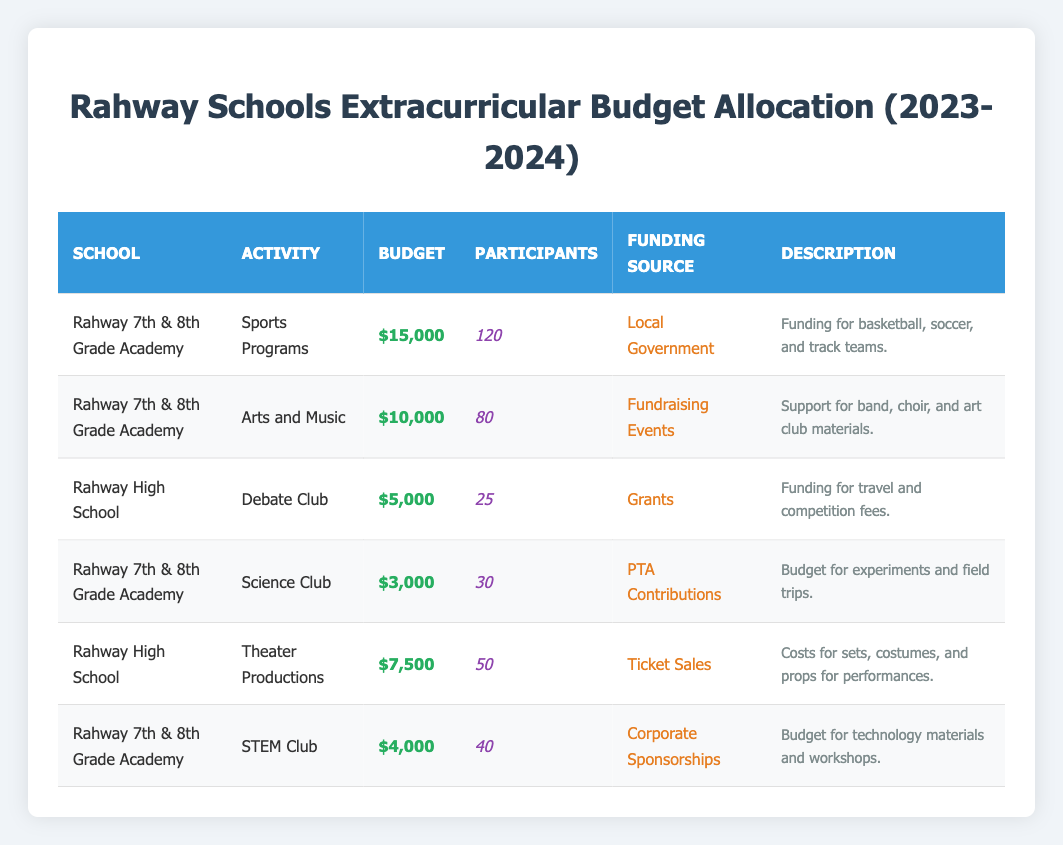What is the allocated budget for the Sports Programs at Rahway 7th & 8th Grade Academy? The table lists the allocated budget for Sports Programs at Rahway 7th & 8th Grade Academy as $15,000.
Answer: $15,000 How many participants are involved in the Arts and Music activities at Rahway 7th & 8th Grade Academy? The table shows that there are 80 participants in the Arts and Music activities at Rahway 7th & 8th Grade Academy.
Answer: 80 Which funding source is used for the Science Club at Rahway 7th & 8th Grade Academy? According to the table, the funding source for the Science Club at Rahway 7th & 8th Grade Academy is PTA Contributions.
Answer: PTA Contributions What is the total budget allocated for extracurricular activities at Rahway 7th & 8th Grade Academy? The table shows the following budgets: Sports Programs ($15,000), Arts and Music ($10,000), Science Club ($3,000), and STEM Club ($4,000). Summing these gives: $15,000 + $10,000 + $3,000 + $4,000 = $32,000.
Answer: $32,000 Is the Debate Club at Rahway High School funded by local government? The table indicates that the funding source for the Debate Club at Rahway High School is Grants, not local government.
Answer: No How much more budget is allocated to Sports Programs compared to the STEM Club at Rahway 7th & 8th Grade Academy? The budget for Sports Programs is $15,000, while for the STEM Club it is $4,000. The difference is calculated as: $15,000 - $4,000 = $11,000.
Answer: $11,000 What percentage of the total budget for Rahway 7th & 8th Grade Academy is allocated to Arts and Music? The total budget for Rahway 7th & 8th Grade Academy is $32,000 (calculated previously). The budget for Arts and Music is $10,000. The percentage is calculated as: ($10,000 / $32,000) * 100 = 31.25%.
Answer: 31.25% Which activity has the greatest number of participants at Rahway 7th & 8th Grade Academy? Comparing the number of participants: Sports Programs has 120, Arts and Music has 80, Science Club has 30, and STEM Club has 40. Therefore, Sports Programs has the greatest number of participants.
Answer: Sports Programs If you combined the budgets for the Theater Productions and Debate Club, what would be the total budget? The budget for Theater Productions at Rahway High School is $7,500 and for the Debate Club, it is $5,000. Adding these gives: $7,500 + $5,000 = $12,500.
Answer: $12,500 For the 2023-2024 academic year, what is the funding source for the Theater Productions at Rahway High School? The table states that the funding source for Theater Productions at Rahway High School is Ticket Sales.
Answer: Ticket Sales 